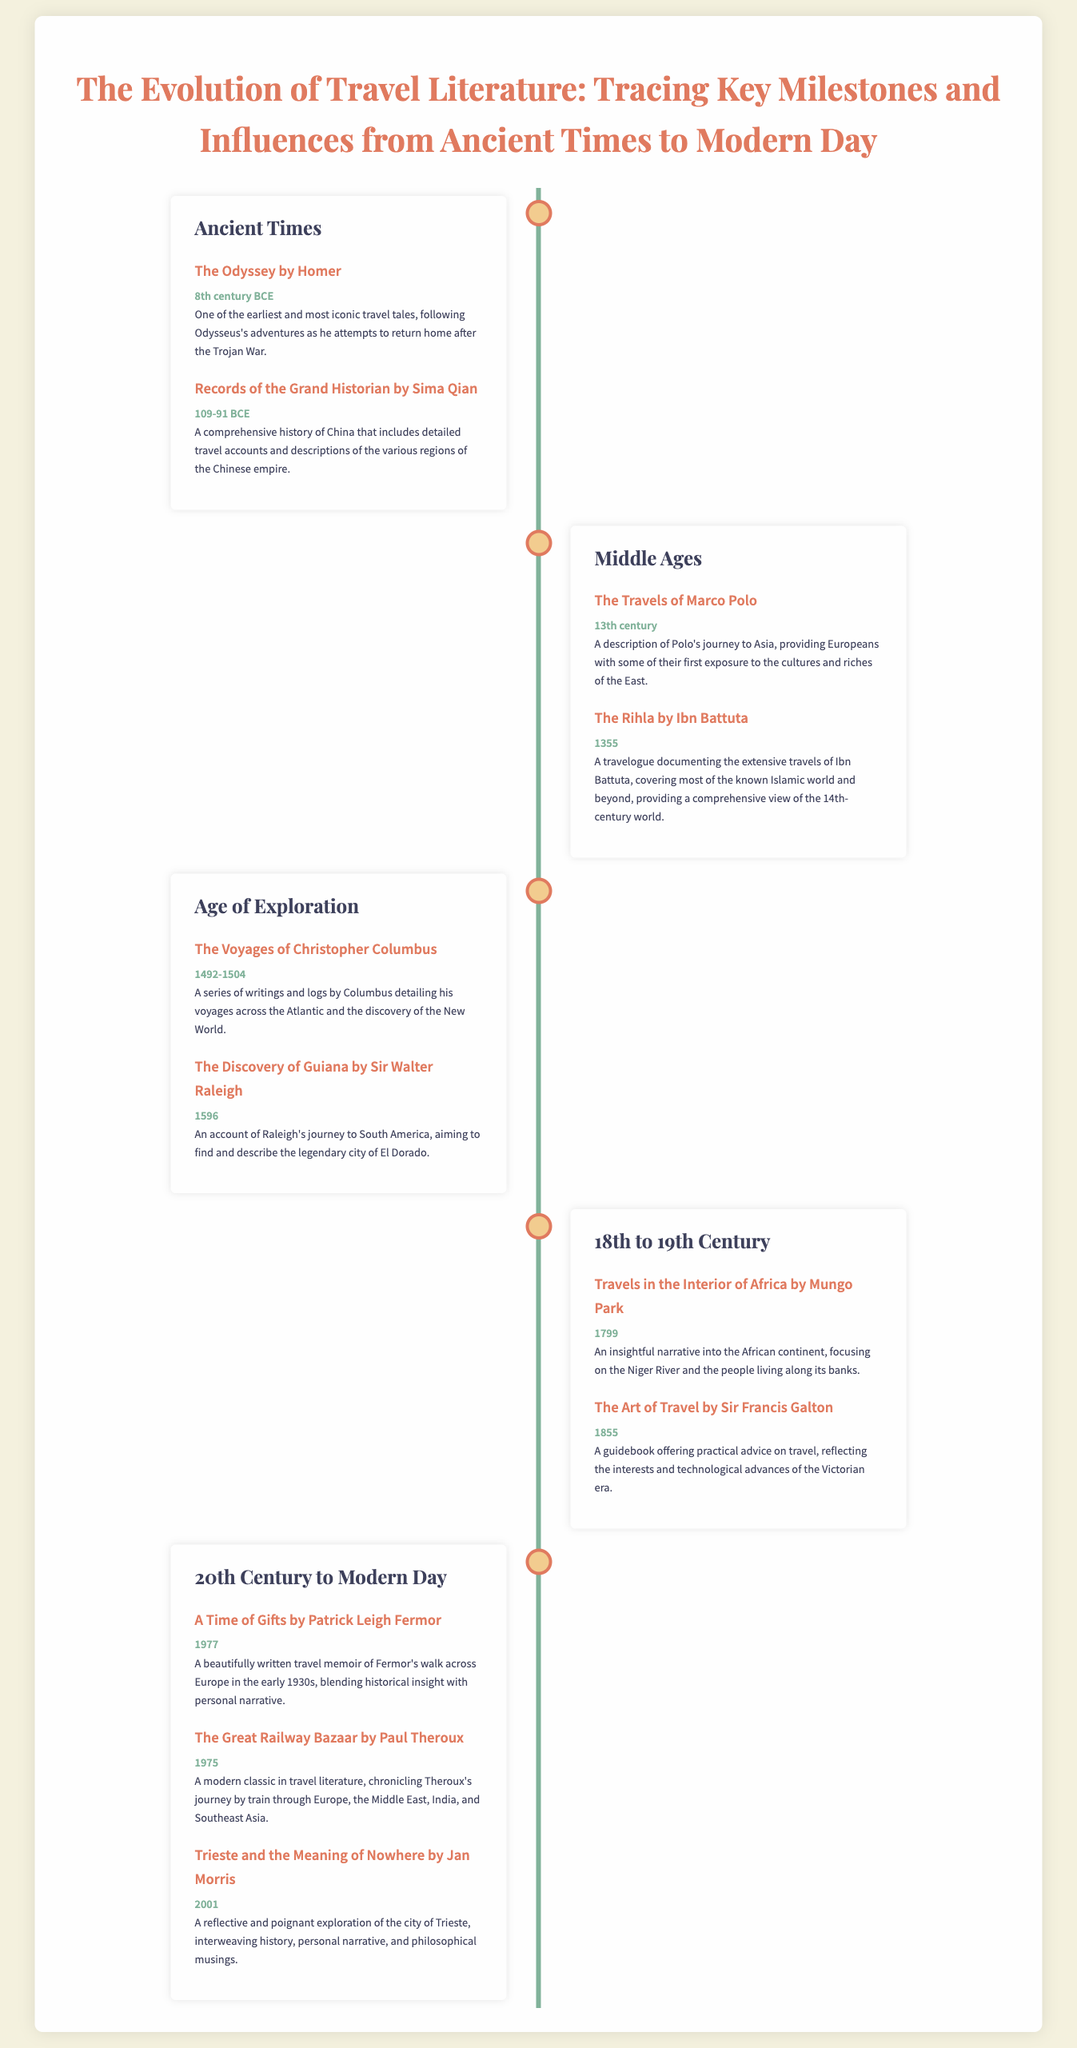What is one of the earliest travel tales? The Odyssey by Homer is mentioned as one of the earliest and most iconic travel tales.
Answer: The Odyssey by Homer What century was The Travels of Marco Polo published? The document states that The Travels of Marco Polo was published in the 13th century.
Answer: 13th century What is the title of the travel book by Jan Morris? The document lists Trieste and the Meaning of Nowhere as the title of the travel book by Jan Morris.
Answer: Trieste and the Meaning of Nowhere Which travel literature work focuses on the Niger River? The document indicates that Travels in the Interior of Africa by Mungo Park focuses on the Niger River.
Answer: Travels in the Interior of Africa by Mungo Park In what year was The Great Railway Bazaar published? The Great Railway Bazaar is noted in the document to have been published in 1975.
Answer: 1975 What period does the milestone "The Rihla by Ibn Battuta" belong to? The document categorizes The Rihla by Ibn Battuta under the Middle Ages period.
Answer: Middle Ages Which author had their work published in 1855? The Art of Travel by Sir Francis Galton is the work published in 1855 according to the document.
Answer: The Art of Travel by Sir Francis Galton What significant journey does A Time of Gifts document? A Time of Gifts documents Patrick Leigh Fermor's walk across Europe.
Answer: walk across Europe What common theme is evident in the travel literature discussed? The common theme in the travel literature includes exploration and cultural experience.
Answer: exploration and cultural experience 